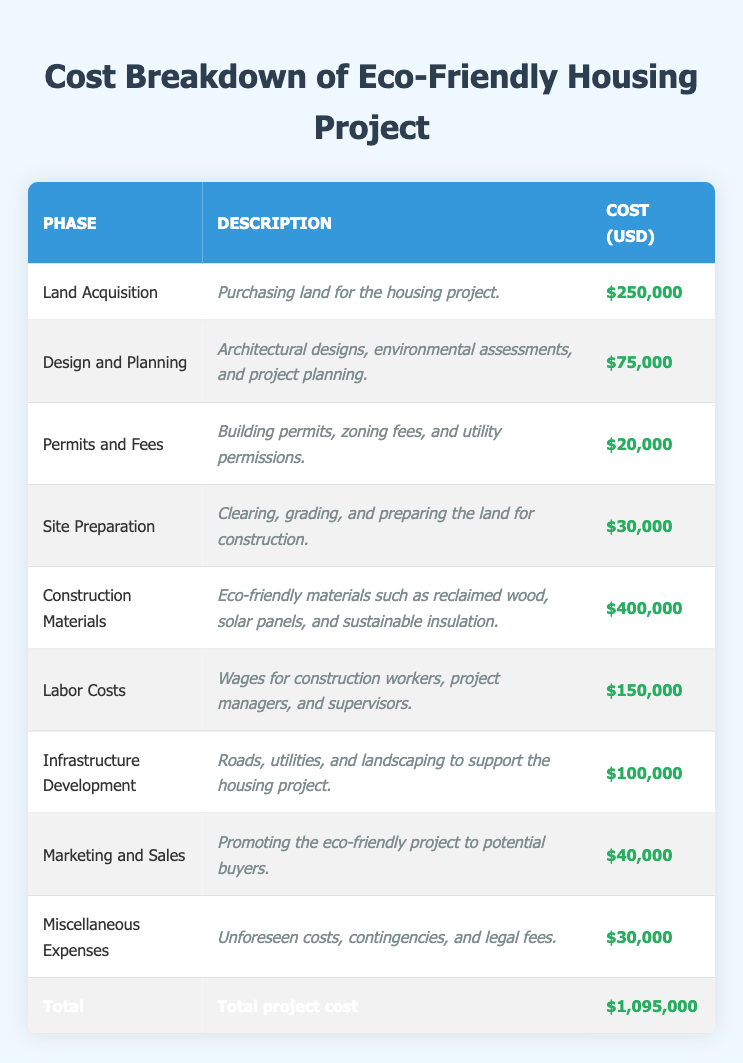What is the total cost of developing the eco-friendly housing project? The total cost is presented in the last row of the table, which is $1,095,000.
Answer: $1,095,000 How much is allocated for construction materials? The cost for construction materials is listed in the table as $400,000.
Answer: $400,000 Is the cost of permits and fees greater than the cost of site preparation? The cost of permits and fees is $20,000 and the cost of site preparation is $30,000. Since $20,000 is less than $30,000, the answer is no.
Answer: No What is the combined cost of land acquisition and infrastructure development? Land acquisition costs $250,000 and infrastructure development costs $100,000. Therefore, the combined cost is $250,000 + $100,000 = $350,000.
Answer: $350,000 Which phase has the highest expense? By analyzing the costs listed in the table, construction materials cost $400,000, which is higher than all other phases.
Answer: Construction Materials What percentage of the total cost is attributed to labor costs? Labor costs are $150,000, and the total cost is $1,095,000. To find the percentage, we calculate ($150,000 / $1,095,000) * 100 ≈ 13.68%.
Answer: 13.68% If we exclude marketing and sales from the total cost, what is the new total? Marketing and sales cost $40,000, so the new total is $1,095,000 - $40,000 = $1,055,000.
Answer: $1,055,000 How much do miscellaneous expenses and permits together contribute to the overall cost? Miscellaneous expenses are $30,000 and permits are $20,000. Therefore, together they contribute $30,000 + $20,000 = $50,000.
Answer: $50,000 What is the difference in cost between construction materials and the combined costs of land acquisition and labor? Construction materials cost $400,000. The combined costs of land acquisition ($250,000) and labor ($150,000) total $400,000. The difference is $400,000 - $400,000 = $0.
Answer: $0 Is it true that design and planning costs are higher than site preparation costs? Design and planning costs $75,000 and site preparation costs $30,000. Since $75,000 is greater than $30,000, the answer is yes.
Answer: Yes 